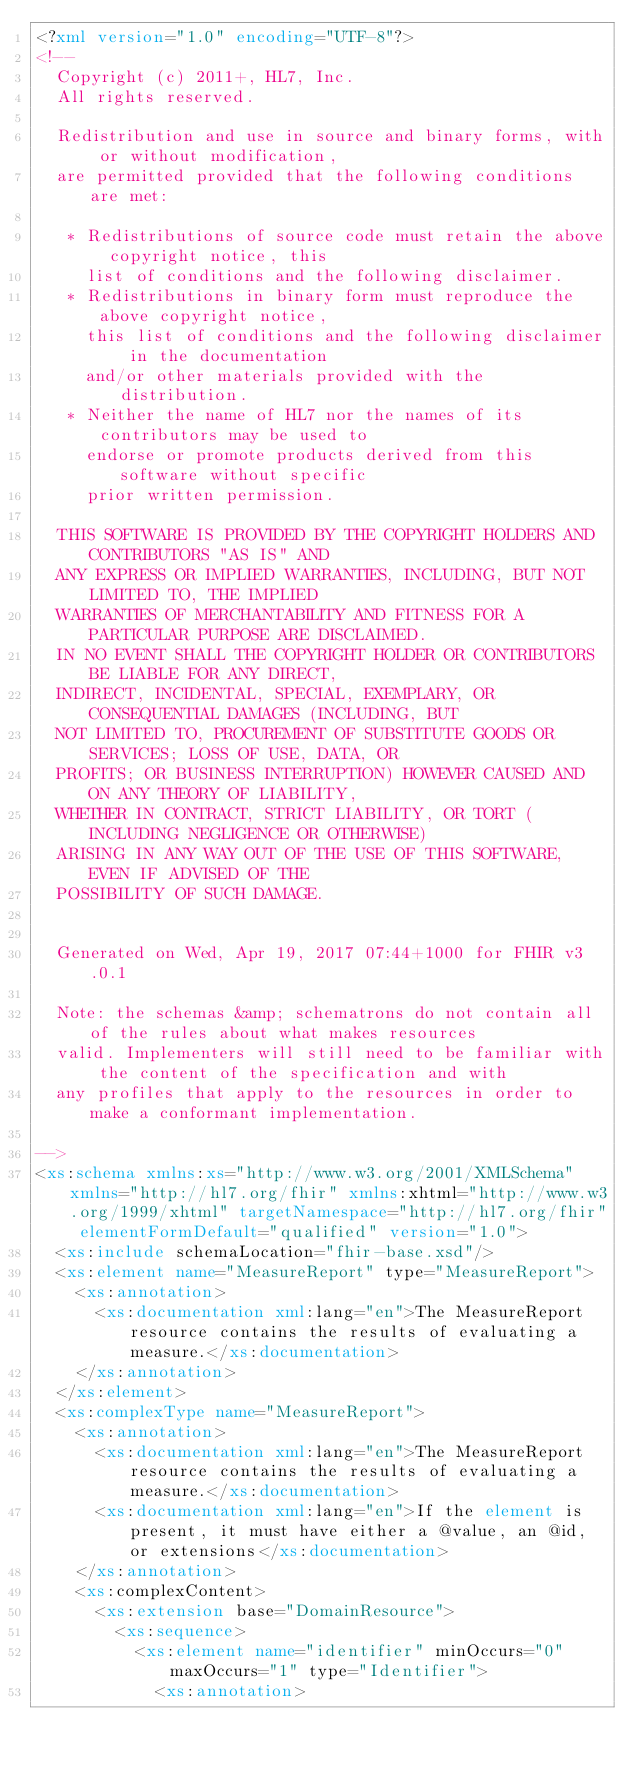<code> <loc_0><loc_0><loc_500><loc_500><_XML_><?xml version="1.0" encoding="UTF-8"?>
<!--
  Copyright (c) 2011+, HL7, Inc.
  All rights reserved.
  
  Redistribution and use in source and binary forms, with or without modification, 
  are permitted provided that the following conditions are met:
  
   * Redistributions of source code must retain the above copyright notice, this 
     list of conditions and the following disclaimer.
   * Redistributions in binary form must reproduce the above copyright notice, 
     this list of conditions and the following disclaimer in the documentation 
     and/or other materials provided with the distribution.
   * Neither the name of HL7 nor the names of its contributors may be used to 
     endorse or promote products derived from this software without specific 
     prior written permission.
  
  THIS SOFTWARE IS PROVIDED BY THE COPYRIGHT HOLDERS AND CONTRIBUTORS "AS IS" AND 
  ANY EXPRESS OR IMPLIED WARRANTIES, INCLUDING, BUT NOT LIMITED TO, THE IMPLIED 
  WARRANTIES OF MERCHANTABILITY AND FITNESS FOR A PARTICULAR PURPOSE ARE DISCLAIMED. 
  IN NO EVENT SHALL THE COPYRIGHT HOLDER OR CONTRIBUTORS BE LIABLE FOR ANY DIRECT, 
  INDIRECT, INCIDENTAL, SPECIAL, EXEMPLARY, OR CONSEQUENTIAL DAMAGES (INCLUDING, BUT 
  NOT LIMITED TO, PROCUREMENT OF SUBSTITUTE GOODS OR SERVICES; LOSS OF USE, DATA, OR 
  PROFITS; OR BUSINESS INTERRUPTION) HOWEVER CAUSED AND ON ANY THEORY OF LIABILITY, 
  WHETHER IN CONTRACT, STRICT LIABILITY, OR TORT (INCLUDING NEGLIGENCE OR OTHERWISE) 
  ARISING IN ANY WAY OUT OF THE USE OF THIS SOFTWARE, EVEN IF ADVISED OF THE 
  POSSIBILITY OF SUCH DAMAGE.
  

  Generated on Wed, Apr 19, 2017 07:44+1000 for FHIR v3.0.1 

  Note: the schemas &amp; schematrons do not contain all of the rules about what makes resources
  valid. Implementers will still need to be familiar with the content of the specification and with
  any profiles that apply to the resources in order to make a conformant implementation.

-->
<xs:schema xmlns:xs="http://www.w3.org/2001/XMLSchema" xmlns="http://hl7.org/fhir" xmlns:xhtml="http://www.w3.org/1999/xhtml" targetNamespace="http://hl7.org/fhir" elementFormDefault="qualified" version="1.0">
  <xs:include schemaLocation="fhir-base.xsd"/>
  <xs:element name="MeasureReport" type="MeasureReport">
    <xs:annotation>
      <xs:documentation xml:lang="en">The MeasureReport resource contains the results of evaluating a measure.</xs:documentation>
    </xs:annotation>
  </xs:element>
  <xs:complexType name="MeasureReport">
    <xs:annotation>
      <xs:documentation xml:lang="en">The MeasureReport resource contains the results of evaluating a measure.</xs:documentation>
      <xs:documentation xml:lang="en">If the element is present, it must have either a @value, an @id, or extensions</xs:documentation>
    </xs:annotation>
    <xs:complexContent>
      <xs:extension base="DomainResource">
        <xs:sequence>
          <xs:element name="identifier" minOccurs="0" maxOccurs="1" type="Identifier">
            <xs:annotation></code> 